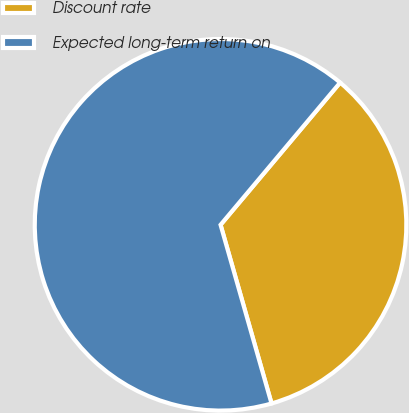Convert chart to OTSL. <chart><loc_0><loc_0><loc_500><loc_500><pie_chart><fcel>Discount rate<fcel>Expected long-term return on<nl><fcel>34.45%<fcel>65.55%<nl></chart> 